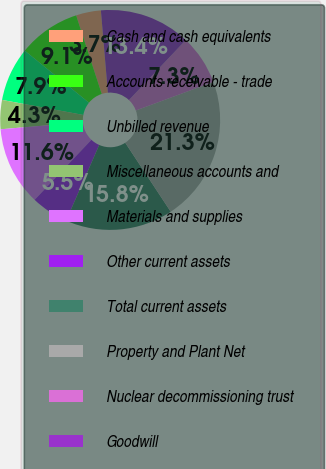Convert chart to OTSL. <chart><loc_0><loc_0><loc_500><loc_500><pie_chart><fcel>Cash and cash equivalents<fcel>Accounts receivable - trade<fcel>Unbilled revenue<fcel>Miscellaneous accounts and<fcel>Materials and supplies<fcel>Other current assets<fcel>Total current assets<fcel>Property and Plant Net<fcel>Nuclear decommissioning trust<fcel>Goodwill<nl><fcel>3.66%<fcel>9.15%<fcel>7.93%<fcel>4.27%<fcel>11.59%<fcel>5.49%<fcel>15.85%<fcel>21.34%<fcel>7.32%<fcel>13.41%<nl></chart> 